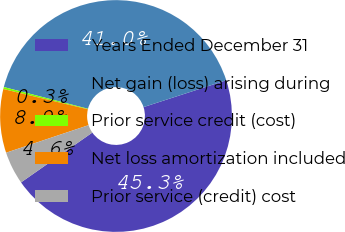Convert chart. <chart><loc_0><loc_0><loc_500><loc_500><pie_chart><fcel>Years Ended December 31<fcel>Net gain (loss) arising during<fcel>Prior service credit (cost)<fcel>Net loss amortization included<fcel>Prior service (credit) cost<nl><fcel>45.28%<fcel>40.99%<fcel>0.28%<fcel>8.87%<fcel>4.58%<nl></chart> 